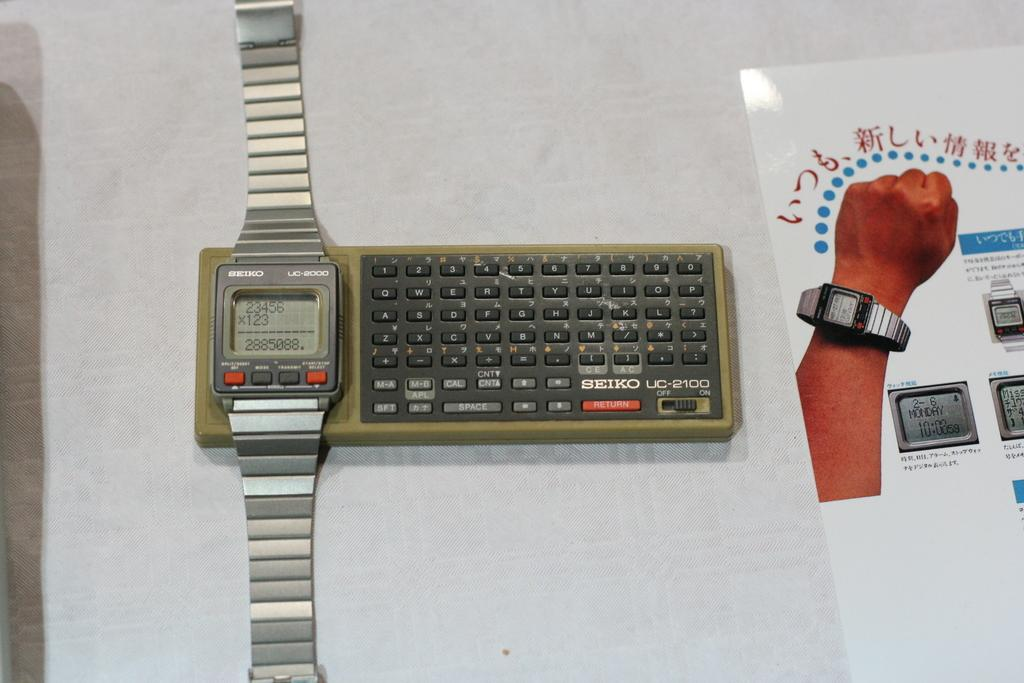<image>
Offer a succinct explanation of the picture presented. An old keyboard with Seiko UC-2100 on it. 